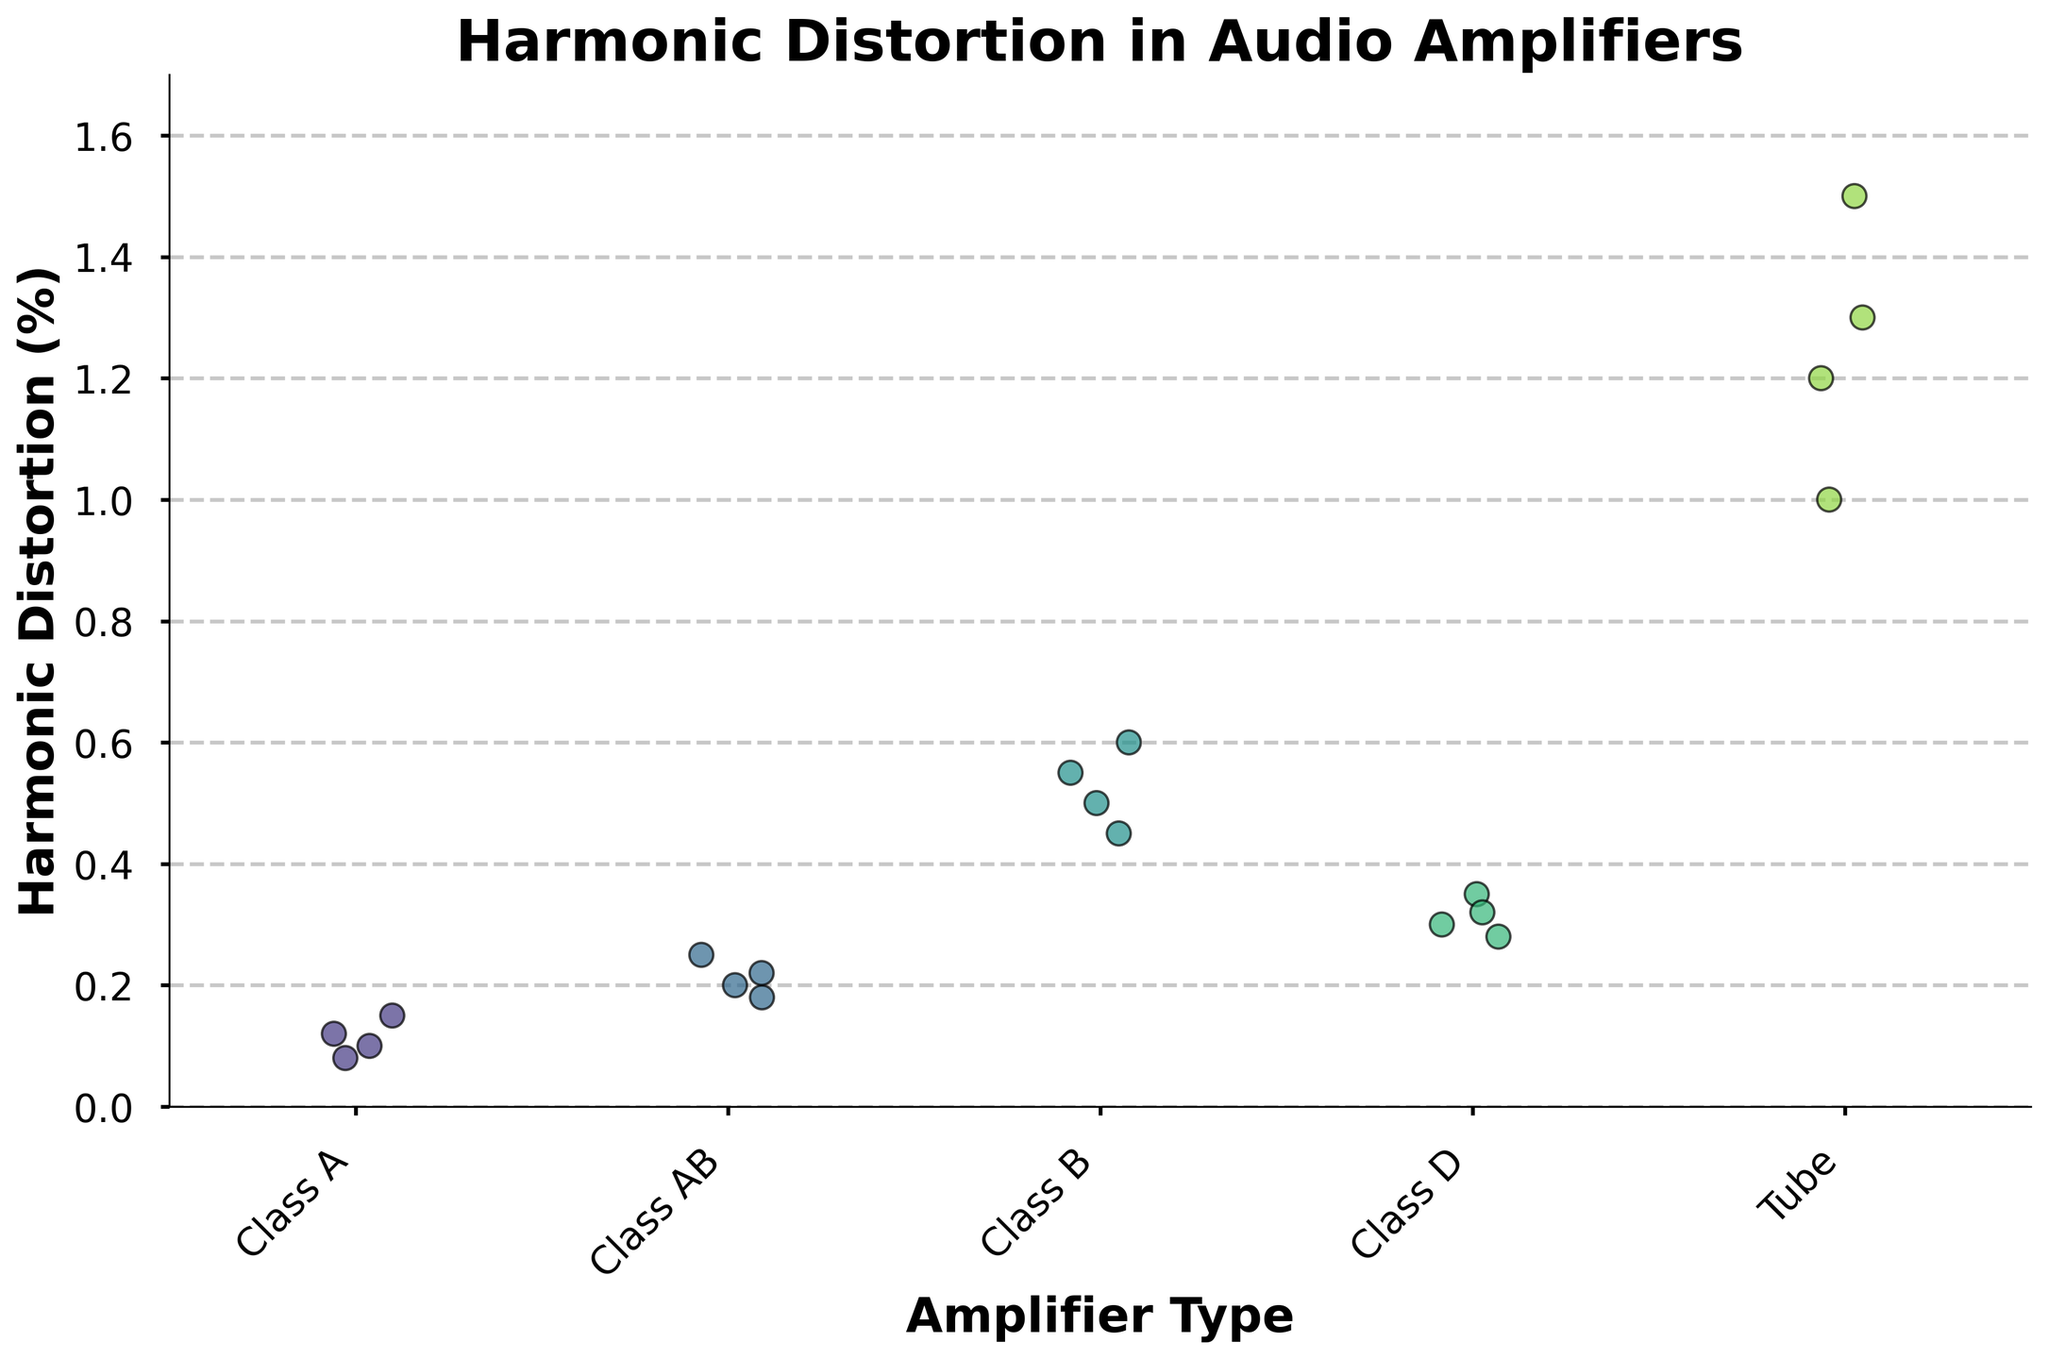What's the main title of the figure? The main title is situated at the top of the figure. It summarizes the key theme or subject of the plot and is usually in a larger and bold font.
Answer: Harmonic Distortion in Audio Amplifiers How many different types of amplifiers are compared in this plot? By counting the unique categories along the x-axis, which represent the different types of amplifiers being compared.
Answer: 5 Which amplifier type has the highest median harmonic distortion percentage? Observing the central tendency of data points for each amplifier type, especially around the middle values. The amplifier type with more points consistent around a higher median value has the highest median distortion.
Answer: Tube What is the average harmonic distortion percentage for Class D amplifiers? Sum the harmonic distortion percentages for all Class D amplifiers and divide by the number of data points for Class D. The relevant data points are 0.3, 0.35, 0.28, and 0.32. Calculate as follows: (0.3 + 0.35 + 0.28 + 0.32) / 4 = 1.25 / 4
Answer: 0.3125 How does the variability in harmonic distortion percentages differ between Class A and Class B amplifiers? By observing the spread or range of data points along the y-axis for both Class A and Class B amplifiers. Variability can be gauged by looking at how tightly or loosely the points are clustered. Class B shows more variability due to the wider spread.
Answer: Class B shows more variability Which amplifier type has the least consistent harmonic distortion percentage? Consistency can be inferred from the spread of data points; the wider the spread, the less consistent the data. Identify the amplifier type with the most dispersed data points.
Answer: Tube Are there any amplifier types whose harmonic distortion percentages do not exceed 0.5%? Check the maximum data points for each amplifier type and see if any type has all data points below 0.5%.
Answer: Class A and Class AB Comparing Class A and Tube amplifiers, which type has data points consistently above 0.9% harmonic distortion? Identify the amplifier types and scan their data points to see if the majority or all points are above 0.9%. Tube amplifiers consistently have points above 0.9%.
Answer: Tube What is the median harmonic distortion percentage for Class AB amplifiers? Arrange the distortion percentages for Class AB amplifiers in ascending order and find the middle value. The values are 0.18, 0.2, 0.22, 0.25, so the median is the average of 0.2 and 0.22. (0.2 + 0.22) / 2
Answer: 0.21 